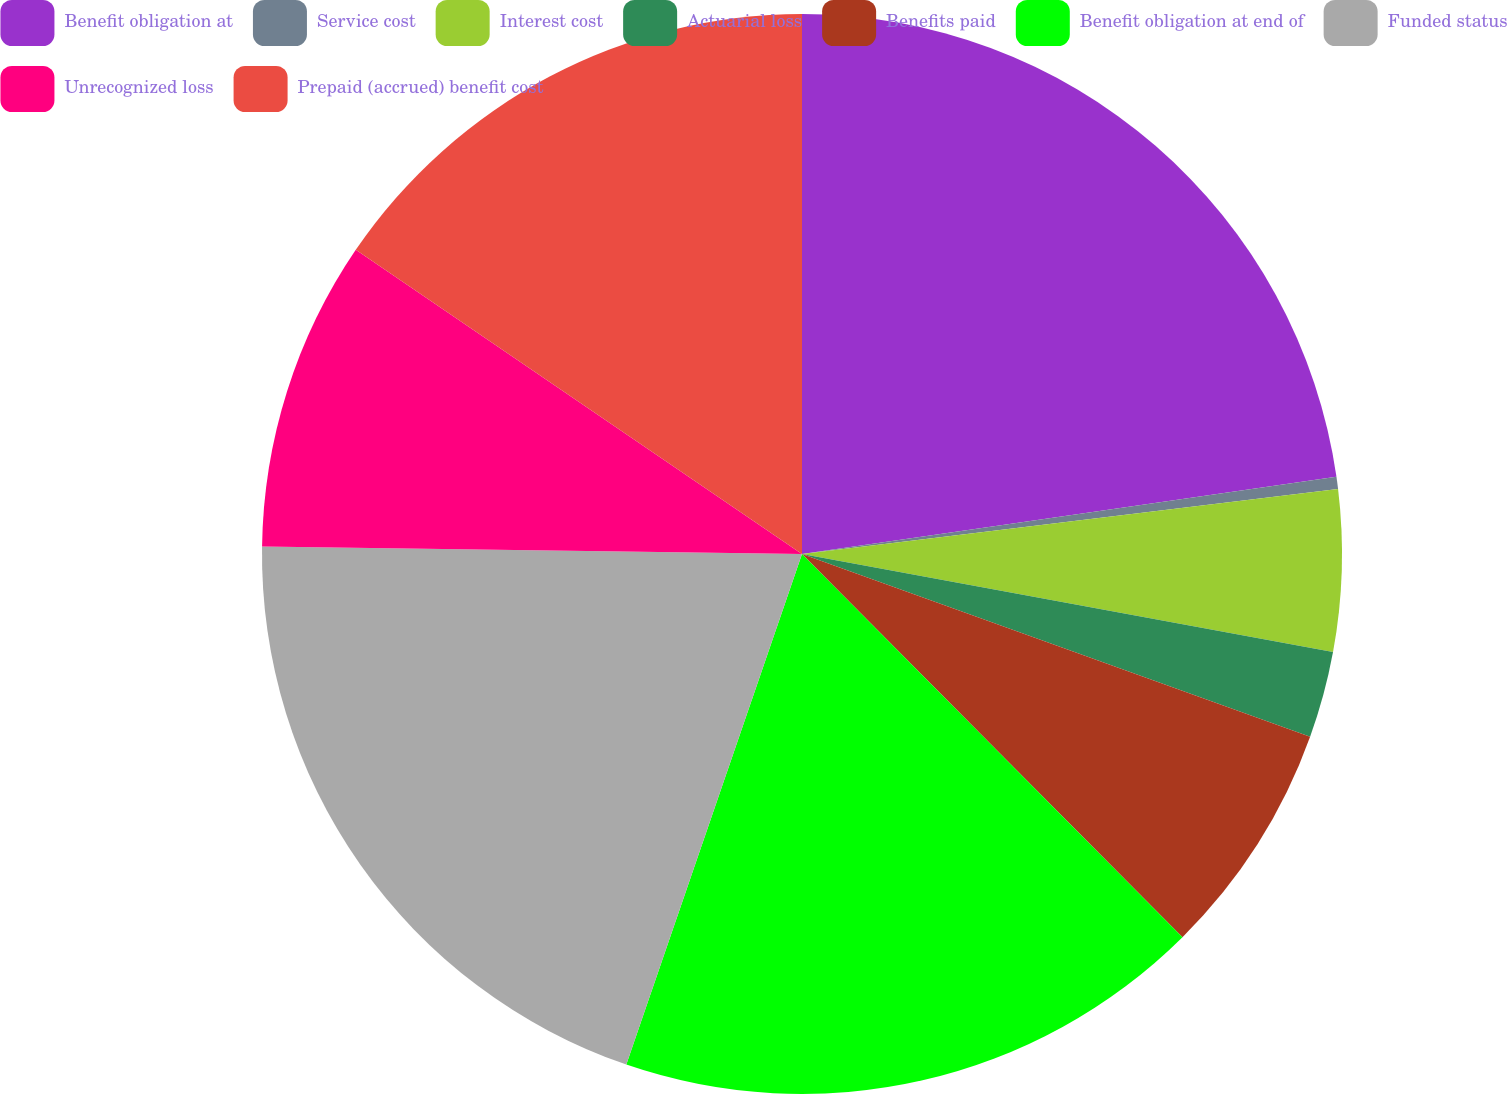Convert chart to OTSL. <chart><loc_0><loc_0><loc_500><loc_500><pie_chart><fcel>Benefit obligation at<fcel>Service cost<fcel>Interest cost<fcel>Actuarial loss<fcel>Benefits paid<fcel>Benefit obligation at end of<fcel>Funded status<fcel>Unrecognized loss<fcel>Prepaid (accrued) benefit cost<nl><fcel>22.72%<fcel>0.36%<fcel>4.83%<fcel>2.59%<fcel>7.06%<fcel>17.72%<fcel>19.95%<fcel>9.3%<fcel>15.48%<nl></chart> 